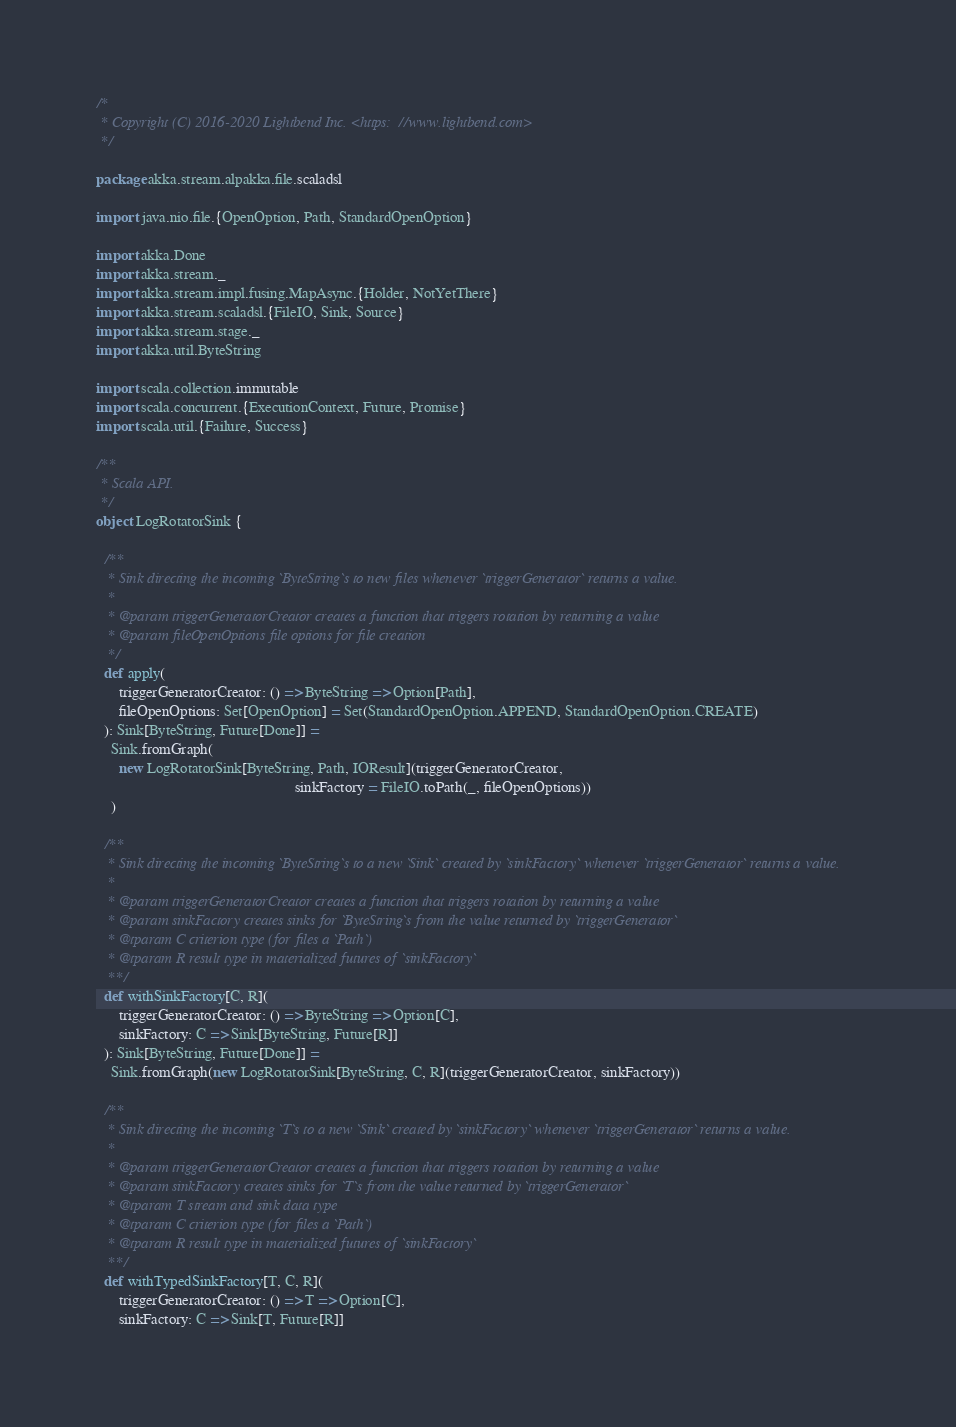<code> <loc_0><loc_0><loc_500><loc_500><_Scala_>/*
 * Copyright (C) 2016-2020 Lightbend Inc. <https://www.lightbend.com>
 */

package akka.stream.alpakka.file.scaladsl

import java.nio.file.{OpenOption, Path, StandardOpenOption}

import akka.Done
import akka.stream._
import akka.stream.impl.fusing.MapAsync.{Holder, NotYetThere}
import akka.stream.scaladsl.{FileIO, Sink, Source}
import akka.stream.stage._
import akka.util.ByteString

import scala.collection.immutable
import scala.concurrent.{ExecutionContext, Future, Promise}
import scala.util.{Failure, Success}

/**
 * Scala API.
 */
object LogRotatorSink {

  /**
   * Sink directing the incoming `ByteString`s to new files whenever `triggerGenerator` returns a value.
   *
   * @param triggerGeneratorCreator creates a function that triggers rotation by returning a value
   * @param fileOpenOptions file options for file creation
   */
  def apply(
      triggerGeneratorCreator: () => ByteString => Option[Path],
      fileOpenOptions: Set[OpenOption] = Set(StandardOpenOption.APPEND, StandardOpenOption.CREATE)
  ): Sink[ByteString, Future[Done]] =
    Sink.fromGraph(
      new LogRotatorSink[ByteString, Path, IOResult](triggerGeneratorCreator,
                                                     sinkFactory = FileIO.toPath(_, fileOpenOptions))
    )

  /**
   * Sink directing the incoming `ByteString`s to a new `Sink` created by `sinkFactory` whenever `triggerGenerator` returns a value.
   *
   * @param triggerGeneratorCreator creates a function that triggers rotation by returning a value
   * @param sinkFactory creates sinks for `ByteString`s from the value returned by `triggerGenerator`
   * @tparam C criterion type (for files a `Path`)
   * @tparam R result type in materialized futures of `sinkFactory`
   **/
  def withSinkFactory[C, R](
      triggerGeneratorCreator: () => ByteString => Option[C],
      sinkFactory: C => Sink[ByteString, Future[R]]
  ): Sink[ByteString, Future[Done]] =
    Sink.fromGraph(new LogRotatorSink[ByteString, C, R](triggerGeneratorCreator, sinkFactory))

  /**
   * Sink directing the incoming `T`s to a new `Sink` created by `sinkFactory` whenever `triggerGenerator` returns a value.
   *
   * @param triggerGeneratorCreator creates a function that triggers rotation by returning a value
   * @param sinkFactory creates sinks for `T`s from the value returned by `triggerGenerator`
   * @tparam T stream and sink data type
   * @tparam C criterion type (for files a `Path`)
   * @tparam R result type in materialized futures of `sinkFactory`
   **/
  def withTypedSinkFactory[T, C, R](
      triggerGeneratorCreator: () => T => Option[C],
      sinkFactory: C => Sink[T, Future[R]]</code> 